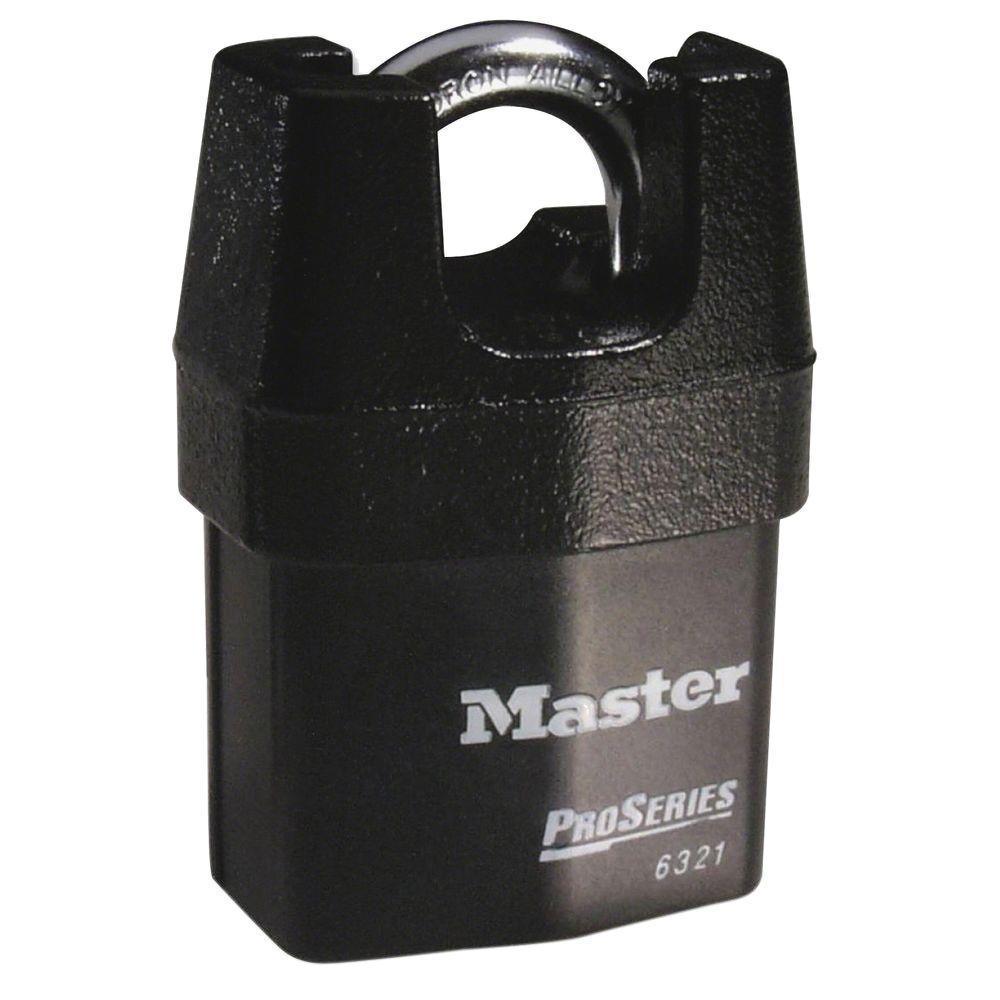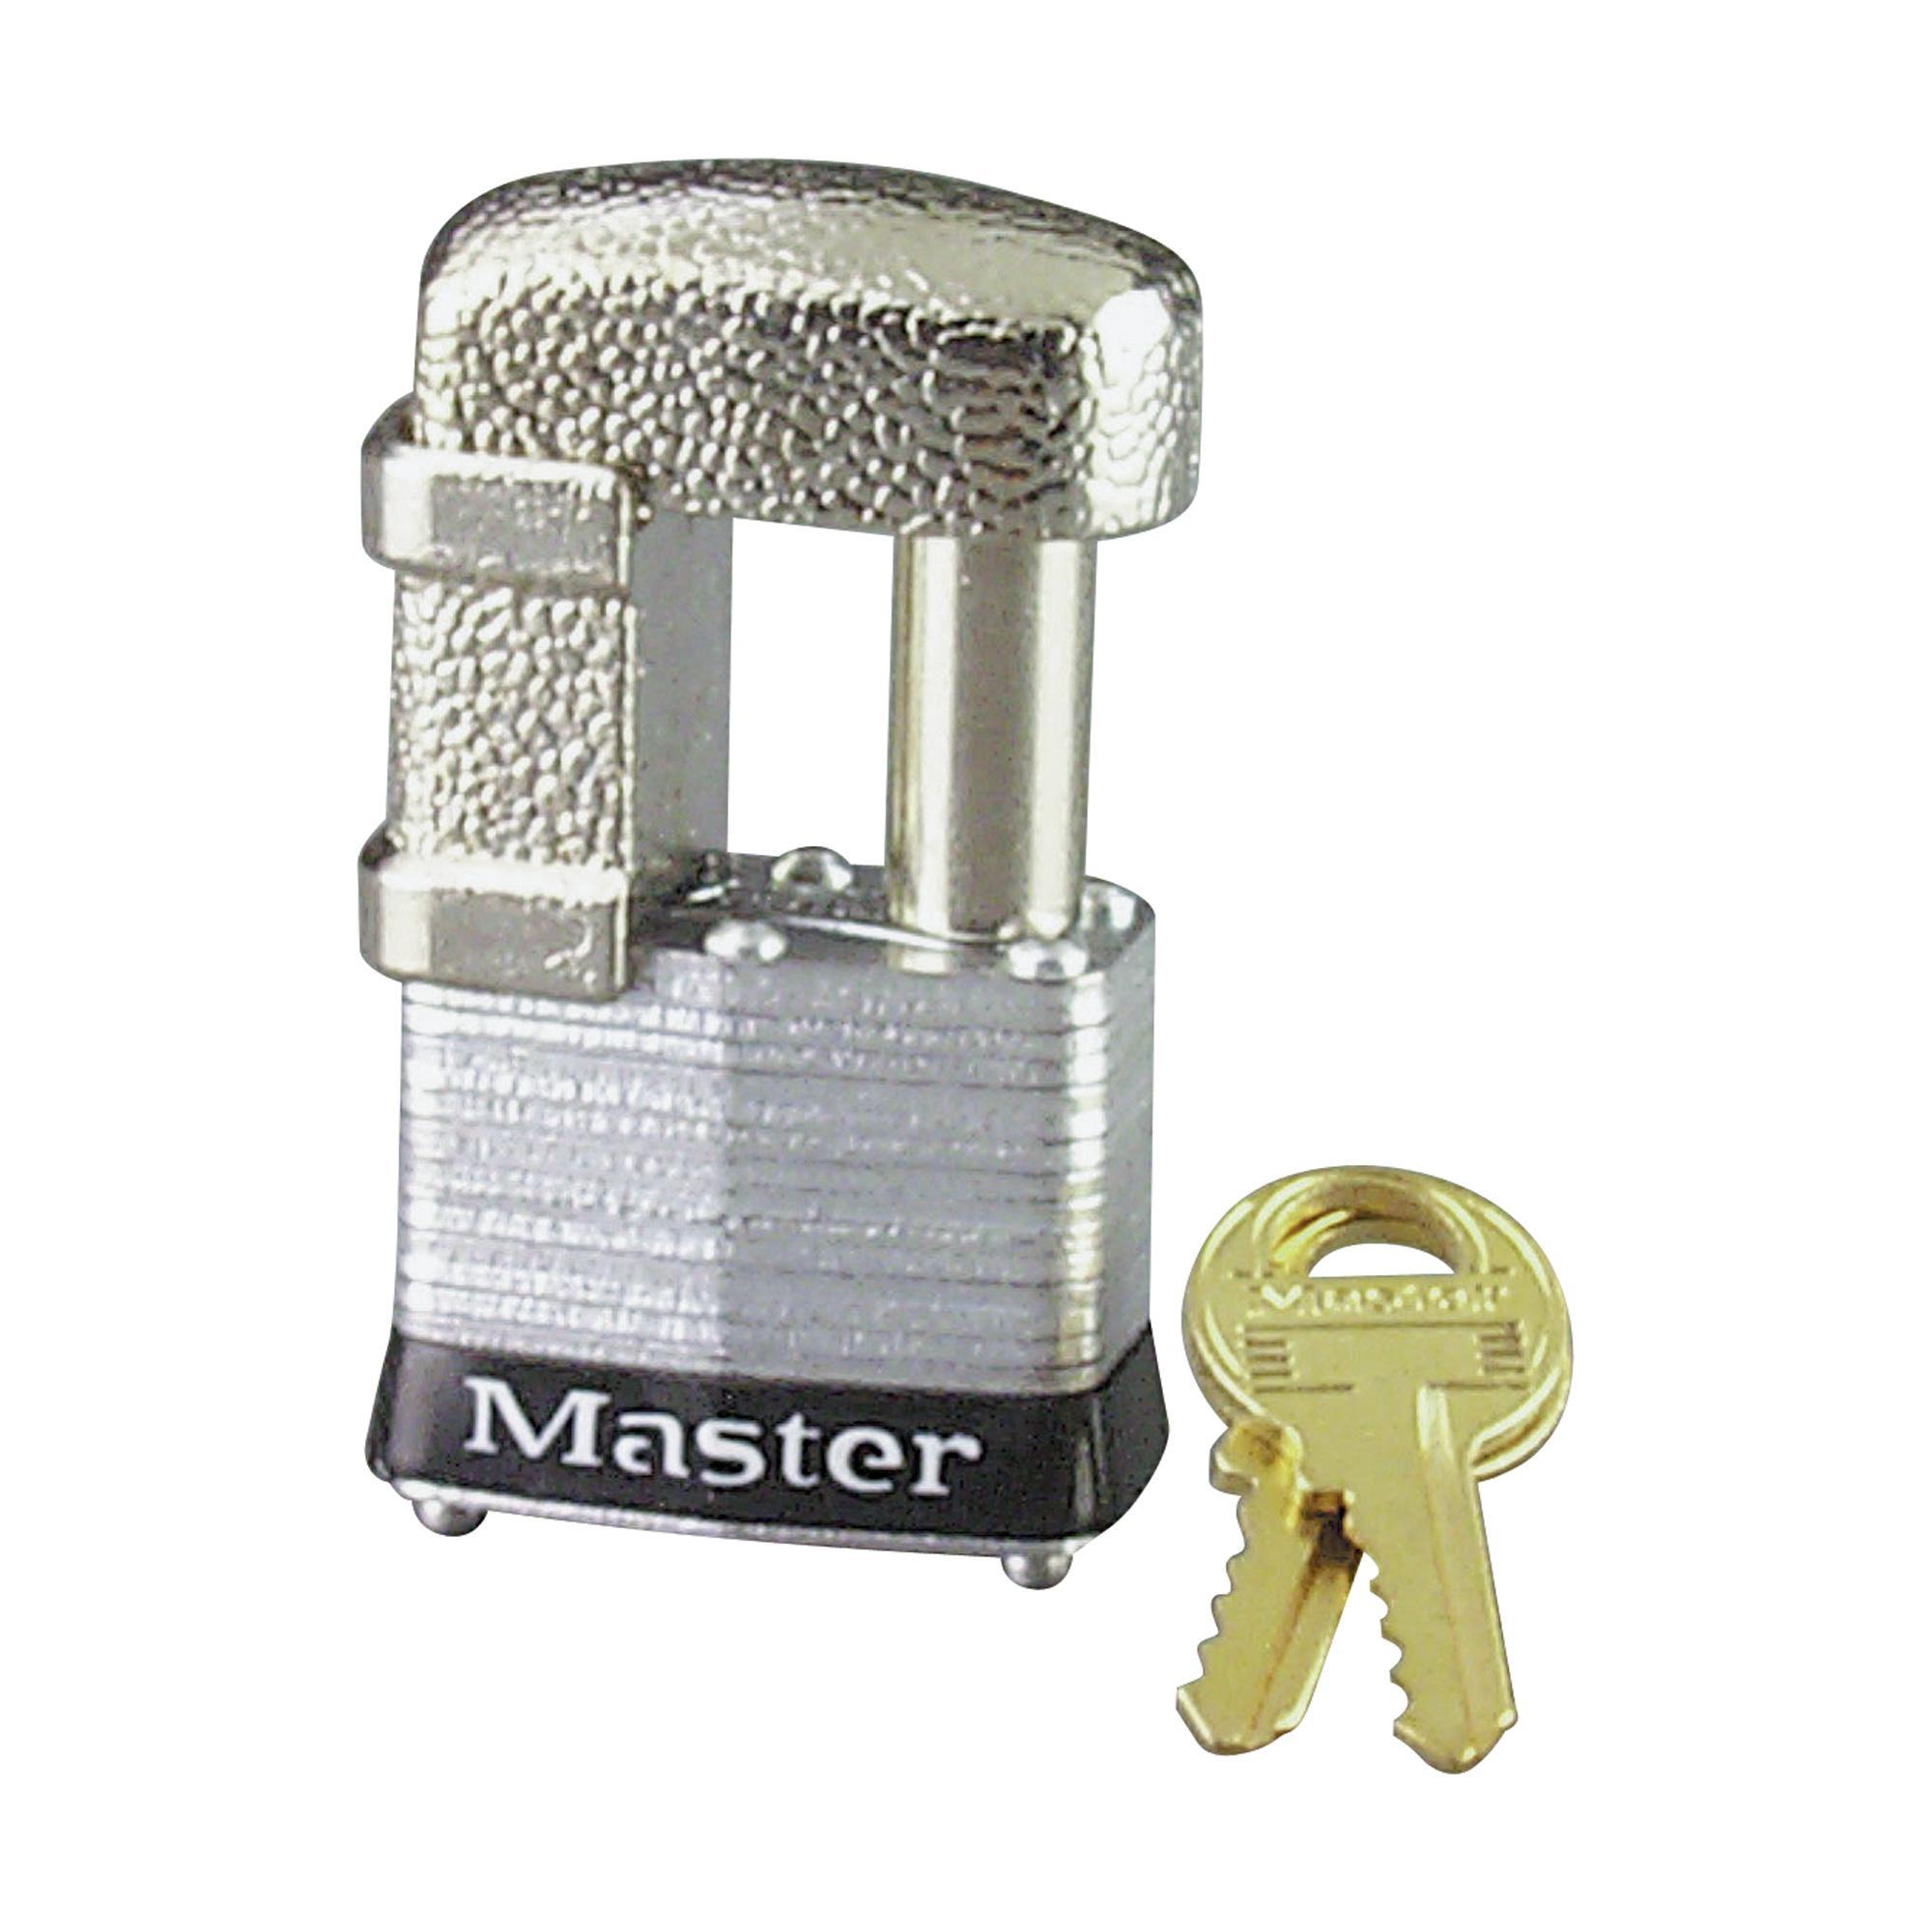The first image is the image on the left, the second image is the image on the right. Given the left and right images, does the statement "There is a pair of gold colored keys beside a lock in one of the images." hold true? Answer yes or no. Yes. The first image is the image on the left, the second image is the image on the right. Considering the images on both sides, is "there are two keys next to a lock" valid? Answer yes or no. Yes. 